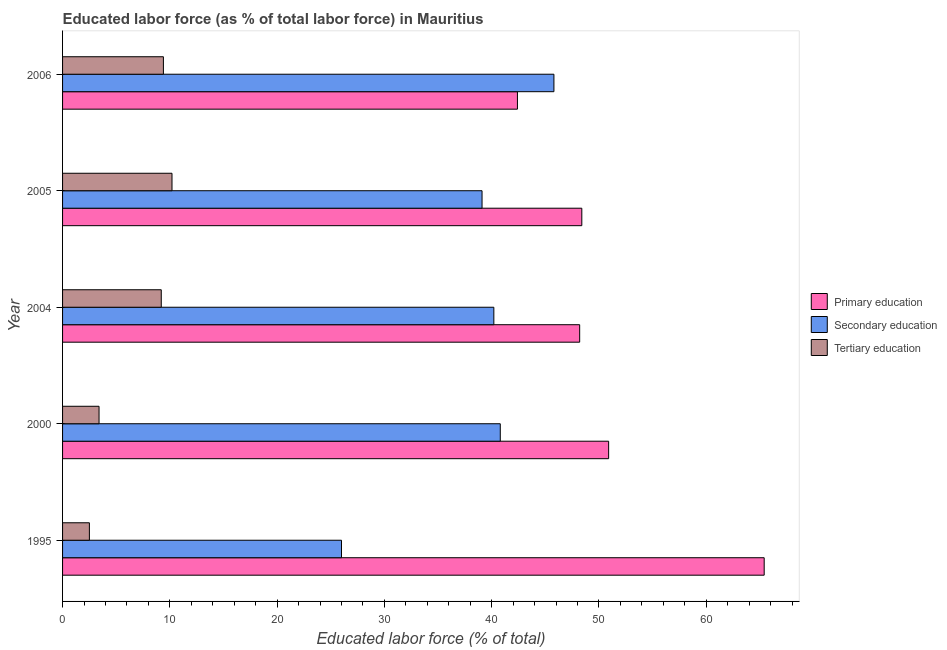Are the number of bars per tick equal to the number of legend labels?
Keep it short and to the point. Yes. Are the number of bars on each tick of the Y-axis equal?
Offer a terse response. Yes. In how many cases, is the number of bars for a given year not equal to the number of legend labels?
Your answer should be very brief. 0. What is the percentage of labor force who received primary education in 1995?
Provide a short and direct response. 65.4. Across all years, what is the maximum percentage of labor force who received primary education?
Offer a very short reply. 65.4. In which year was the percentage of labor force who received secondary education maximum?
Provide a short and direct response. 2006. What is the total percentage of labor force who received tertiary education in the graph?
Keep it short and to the point. 34.7. What is the difference between the percentage of labor force who received tertiary education in 2004 and that in 2005?
Offer a very short reply. -1. What is the difference between the percentage of labor force who received primary education in 1995 and the percentage of labor force who received secondary education in 2005?
Provide a short and direct response. 26.3. What is the average percentage of labor force who received secondary education per year?
Provide a succinct answer. 38.38. In how many years, is the percentage of labor force who received tertiary education greater than 54 %?
Make the answer very short. 0. What is the ratio of the percentage of labor force who received primary education in 2000 to that in 2004?
Your response must be concise. 1.06. Is the difference between the percentage of labor force who received tertiary education in 2000 and 2006 greater than the difference between the percentage of labor force who received primary education in 2000 and 2006?
Offer a very short reply. No. What is the difference between the highest and the second highest percentage of labor force who received secondary education?
Make the answer very short. 5. What is the difference between the highest and the lowest percentage of labor force who received secondary education?
Make the answer very short. 19.8. In how many years, is the percentage of labor force who received secondary education greater than the average percentage of labor force who received secondary education taken over all years?
Provide a short and direct response. 4. Is the sum of the percentage of labor force who received tertiary education in 1995 and 2004 greater than the maximum percentage of labor force who received secondary education across all years?
Offer a very short reply. No. What does the 3rd bar from the bottom in 2000 represents?
Offer a terse response. Tertiary education. How many years are there in the graph?
Provide a succinct answer. 5. What is the difference between two consecutive major ticks on the X-axis?
Make the answer very short. 10. Does the graph contain grids?
Offer a terse response. No. Where does the legend appear in the graph?
Your answer should be very brief. Center right. How many legend labels are there?
Offer a terse response. 3. How are the legend labels stacked?
Give a very brief answer. Vertical. What is the title of the graph?
Offer a very short reply. Educated labor force (as % of total labor force) in Mauritius. What is the label or title of the X-axis?
Provide a succinct answer. Educated labor force (% of total). What is the Educated labor force (% of total) in Primary education in 1995?
Your response must be concise. 65.4. What is the Educated labor force (% of total) in Primary education in 2000?
Ensure brevity in your answer.  50.9. What is the Educated labor force (% of total) in Secondary education in 2000?
Your answer should be very brief. 40.8. What is the Educated labor force (% of total) of Tertiary education in 2000?
Make the answer very short. 3.4. What is the Educated labor force (% of total) in Primary education in 2004?
Your response must be concise. 48.2. What is the Educated labor force (% of total) in Secondary education in 2004?
Give a very brief answer. 40.2. What is the Educated labor force (% of total) of Tertiary education in 2004?
Make the answer very short. 9.2. What is the Educated labor force (% of total) in Primary education in 2005?
Offer a very short reply. 48.4. What is the Educated labor force (% of total) in Secondary education in 2005?
Provide a short and direct response. 39.1. What is the Educated labor force (% of total) in Tertiary education in 2005?
Offer a very short reply. 10.2. What is the Educated labor force (% of total) of Primary education in 2006?
Ensure brevity in your answer.  42.4. What is the Educated labor force (% of total) of Secondary education in 2006?
Make the answer very short. 45.8. What is the Educated labor force (% of total) in Tertiary education in 2006?
Your answer should be compact. 9.4. Across all years, what is the maximum Educated labor force (% of total) of Primary education?
Give a very brief answer. 65.4. Across all years, what is the maximum Educated labor force (% of total) in Secondary education?
Ensure brevity in your answer.  45.8. Across all years, what is the maximum Educated labor force (% of total) of Tertiary education?
Ensure brevity in your answer.  10.2. Across all years, what is the minimum Educated labor force (% of total) of Primary education?
Give a very brief answer. 42.4. Across all years, what is the minimum Educated labor force (% of total) of Secondary education?
Your answer should be very brief. 26. What is the total Educated labor force (% of total) of Primary education in the graph?
Keep it short and to the point. 255.3. What is the total Educated labor force (% of total) of Secondary education in the graph?
Provide a succinct answer. 191.9. What is the total Educated labor force (% of total) of Tertiary education in the graph?
Your answer should be compact. 34.7. What is the difference between the Educated labor force (% of total) of Primary education in 1995 and that in 2000?
Your answer should be compact. 14.5. What is the difference between the Educated labor force (% of total) of Secondary education in 1995 and that in 2000?
Keep it short and to the point. -14.8. What is the difference between the Educated labor force (% of total) of Tertiary education in 1995 and that in 2000?
Provide a succinct answer. -0.9. What is the difference between the Educated labor force (% of total) in Secondary education in 1995 and that in 2004?
Offer a terse response. -14.2. What is the difference between the Educated labor force (% of total) in Tertiary education in 1995 and that in 2004?
Ensure brevity in your answer.  -6.7. What is the difference between the Educated labor force (% of total) of Secondary education in 1995 and that in 2006?
Offer a terse response. -19.8. What is the difference between the Educated labor force (% of total) in Tertiary education in 1995 and that in 2006?
Ensure brevity in your answer.  -6.9. What is the difference between the Educated labor force (% of total) of Secondary education in 2000 and that in 2004?
Your answer should be very brief. 0.6. What is the difference between the Educated labor force (% of total) in Primary education in 2000 and that in 2005?
Your answer should be very brief. 2.5. What is the difference between the Educated labor force (% of total) of Secondary education in 2000 and that in 2005?
Give a very brief answer. 1.7. What is the difference between the Educated labor force (% of total) of Primary education in 2000 and that in 2006?
Your answer should be very brief. 8.5. What is the difference between the Educated labor force (% of total) of Tertiary education in 2000 and that in 2006?
Ensure brevity in your answer.  -6. What is the difference between the Educated labor force (% of total) of Primary education in 2005 and that in 2006?
Ensure brevity in your answer.  6. What is the difference between the Educated labor force (% of total) in Secondary education in 2005 and that in 2006?
Your answer should be very brief. -6.7. What is the difference between the Educated labor force (% of total) of Primary education in 1995 and the Educated labor force (% of total) of Secondary education in 2000?
Make the answer very short. 24.6. What is the difference between the Educated labor force (% of total) of Primary education in 1995 and the Educated labor force (% of total) of Tertiary education in 2000?
Make the answer very short. 62. What is the difference between the Educated labor force (% of total) of Secondary education in 1995 and the Educated labor force (% of total) of Tertiary education in 2000?
Offer a terse response. 22.6. What is the difference between the Educated labor force (% of total) of Primary education in 1995 and the Educated labor force (% of total) of Secondary education in 2004?
Make the answer very short. 25.2. What is the difference between the Educated labor force (% of total) of Primary education in 1995 and the Educated labor force (% of total) of Tertiary education in 2004?
Provide a short and direct response. 56.2. What is the difference between the Educated labor force (% of total) in Secondary education in 1995 and the Educated labor force (% of total) in Tertiary education in 2004?
Give a very brief answer. 16.8. What is the difference between the Educated labor force (% of total) in Primary education in 1995 and the Educated labor force (% of total) in Secondary education in 2005?
Your answer should be compact. 26.3. What is the difference between the Educated labor force (% of total) of Primary education in 1995 and the Educated labor force (% of total) of Tertiary education in 2005?
Provide a short and direct response. 55.2. What is the difference between the Educated labor force (% of total) of Secondary education in 1995 and the Educated labor force (% of total) of Tertiary education in 2005?
Provide a succinct answer. 15.8. What is the difference between the Educated labor force (% of total) in Primary education in 1995 and the Educated labor force (% of total) in Secondary education in 2006?
Keep it short and to the point. 19.6. What is the difference between the Educated labor force (% of total) in Primary education in 1995 and the Educated labor force (% of total) in Tertiary education in 2006?
Provide a succinct answer. 56. What is the difference between the Educated labor force (% of total) in Secondary education in 1995 and the Educated labor force (% of total) in Tertiary education in 2006?
Offer a terse response. 16.6. What is the difference between the Educated labor force (% of total) in Primary education in 2000 and the Educated labor force (% of total) in Secondary education in 2004?
Your answer should be very brief. 10.7. What is the difference between the Educated labor force (% of total) in Primary education in 2000 and the Educated labor force (% of total) in Tertiary education in 2004?
Your answer should be very brief. 41.7. What is the difference between the Educated labor force (% of total) in Secondary education in 2000 and the Educated labor force (% of total) in Tertiary education in 2004?
Offer a terse response. 31.6. What is the difference between the Educated labor force (% of total) of Primary education in 2000 and the Educated labor force (% of total) of Secondary education in 2005?
Your answer should be compact. 11.8. What is the difference between the Educated labor force (% of total) in Primary education in 2000 and the Educated labor force (% of total) in Tertiary education in 2005?
Your answer should be compact. 40.7. What is the difference between the Educated labor force (% of total) in Secondary education in 2000 and the Educated labor force (% of total) in Tertiary education in 2005?
Provide a short and direct response. 30.6. What is the difference between the Educated labor force (% of total) of Primary education in 2000 and the Educated labor force (% of total) of Secondary education in 2006?
Provide a short and direct response. 5.1. What is the difference between the Educated labor force (% of total) in Primary education in 2000 and the Educated labor force (% of total) in Tertiary education in 2006?
Provide a succinct answer. 41.5. What is the difference between the Educated labor force (% of total) of Secondary education in 2000 and the Educated labor force (% of total) of Tertiary education in 2006?
Make the answer very short. 31.4. What is the difference between the Educated labor force (% of total) of Primary education in 2004 and the Educated labor force (% of total) of Tertiary education in 2006?
Offer a terse response. 38.8. What is the difference between the Educated labor force (% of total) of Secondary education in 2004 and the Educated labor force (% of total) of Tertiary education in 2006?
Offer a very short reply. 30.8. What is the difference between the Educated labor force (% of total) of Primary education in 2005 and the Educated labor force (% of total) of Secondary education in 2006?
Provide a short and direct response. 2.6. What is the difference between the Educated labor force (% of total) in Secondary education in 2005 and the Educated labor force (% of total) in Tertiary education in 2006?
Offer a very short reply. 29.7. What is the average Educated labor force (% of total) in Primary education per year?
Make the answer very short. 51.06. What is the average Educated labor force (% of total) in Secondary education per year?
Your answer should be very brief. 38.38. What is the average Educated labor force (% of total) in Tertiary education per year?
Your answer should be very brief. 6.94. In the year 1995, what is the difference between the Educated labor force (% of total) of Primary education and Educated labor force (% of total) of Secondary education?
Provide a succinct answer. 39.4. In the year 1995, what is the difference between the Educated labor force (% of total) of Primary education and Educated labor force (% of total) of Tertiary education?
Your answer should be very brief. 62.9. In the year 2000, what is the difference between the Educated labor force (% of total) of Primary education and Educated labor force (% of total) of Secondary education?
Give a very brief answer. 10.1. In the year 2000, what is the difference between the Educated labor force (% of total) in Primary education and Educated labor force (% of total) in Tertiary education?
Ensure brevity in your answer.  47.5. In the year 2000, what is the difference between the Educated labor force (% of total) in Secondary education and Educated labor force (% of total) in Tertiary education?
Provide a short and direct response. 37.4. In the year 2004, what is the difference between the Educated labor force (% of total) of Primary education and Educated labor force (% of total) of Secondary education?
Provide a succinct answer. 8. In the year 2004, what is the difference between the Educated labor force (% of total) in Secondary education and Educated labor force (% of total) in Tertiary education?
Keep it short and to the point. 31. In the year 2005, what is the difference between the Educated labor force (% of total) of Primary education and Educated labor force (% of total) of Secondary education?
Your answer should be very brief. 9.3. In the year 2005, what is the difference between the Educated labor force (% of total) in Primary education and Educated labor force (% of total) in Tertiary education?
Your answer should be compact. 38.2. In the year 2005, what is the difference between the Educated labor force (% of total) in Secondary education and Educated labor force (% of total) in Tertiary education?
Keep it short and to the point. 28.9. In the year 2006, what is the difference between the Educated labor force (% of total) of Primary education and Educated labor force (% of total) of Secondary education?
Give a very brief answer. -3.4. In the year 2006, what is the difference between the Educated labor force (% of total) of Secondary education and Educated labor force (% of total) of Tertiary education?
Offer a very short reply. 36.4. What is the ratio of the Educated labor force (% of total) of Primary education in 1995 to that in 2000?
Provide a short and direct response. 1.28. What is the ratio of the Educated labor force (% of total) in Secondary education in 1995 to that in 2000?
Keep it short and to the point. 0.64. What is the ratio of the Educated labor force (% of total) of Tertiary education in 1995 to that in 2000?
Make the answer very short. 0.74. What is the ratio of the Educated labor force (% of total) of Primary education in 1995 to that in 2004?
Your response must be concise. 1.36. What is the ratio of the Educated labor force (% of total) of Secondary education in 1995 to that in 2004?
Your answer should be compact. 0.65. What is the ratio of the Educated labor force (% of total) of Tertiary education in 1995 to that in 2004?
Your answer should be compact. 0.27. What is the ratio of the Educated labor force (% of total) in Primary education in 1995 to that in 2005?
Make the answer very short. 1.35. What is the ratio of the Educated labor force (% of total) of Secondary education in 1995 to that in 2005?
Ensure brevity in your answer.  0.67. What is the ratio of the Educated labor force (% of total) in Tertiary education in 1995 to that in 2005?
Your response must be concise. 0.25. What is the ratio of the Educated labor force (% of total) of Primary education in 1995 to that in 2006?
Your answer should be compact. 1.54. What is the ratio of the Educated labor force (% of total) of Secondary education in 1995 to that in 2006?
Give a very brief answer. 0.57. What is the ratio of the Educated labor force (% of total) in Tertiary education in 1995 to that in 2006?
Offer a terse response. 0.27. What is the ratio of the Educated labor force (% of total) of Primary education in 2000 to that in 2004?
Keep it short and to the point. 1.06. What is the ratio of the Educated labor force (% of total) of Secondary education in 2000 to that in 2004?
Make the answer very short. 1.01. What is the ratio of the Educated labor force (% of total) in Tertiary education in 2000 to that in 2004?
Provide a short and direct response. 0.37. What is the ratio of the Educated labor force (% of total) of Primary education in 2000 to that in 2005?
Your answer should be very brief. 1.05. What is the ratio of the Educated labor force (% of total) in Secondary education in 2000 to that in 2005?
Provide a succinct answer. 1.04. What is the ratio of the Educated labor force (% of total) of Tertiary education in 2000 to that in 2005?
Offer a terse response. 0.33. What is the ratio of the Educated labor force (% of total) in Primary education in 2000 to that in 2006?
Offer a very short reply. 1.2. What is the ratio of the Educated labor force (% of total) of Secondary education in 2000 to that in 2006?
Provide a succinct answer. 0.89. What is the ratio of the Educated labor force (% of total) in Tertiary education in 2000 to that in 2006?
Your answer should be compact. 0.36. What is the ratio of the Educated labor force (% of total) in Primary education in 2004 to that in 2005?
Give a very brief answer. 1. What is the ratio of the Educated labor force (% of total) in Secondary education in 2004 to that in 2005?
Your response must be concise. 1.03. What is the ratio of the Educated labor force (% of total) of Tertiary education in 2004 to that in 2005?
Make the answer very short. 0.9. What is the ratio of the Educated labor force (% of total) of Primary education in 2004 to that in 2006?
Your answer should be compact. 1.14. What is the ratio of the Educated labor force (% of total) of Secondary education in 2004 to that in 2006?
Your answer should be compact. 0.88. What is the ratio of the Educated labor force (% of total) in Tertiary education in 2004 to that in 2006?
Make the answer very short. 0.98. What is the ratio of the Educated labor force (% of total) in Primary education in 2005 to that in 2006?
Offer a very short reply. 1.14. What is the ratio of the Educated labor force (% of total) of Secondary education in 2005 to that in 2006?
Keep it short and to the point. 0.85. What is the ratio of the Educated labor force (% of total) of Tertiary education in 2005 to that in 2006?
Offer a terse response. 1.09. What is the difference between the highest and the second highest Educated labor force (% of total) in Secondary education?
Offer a terse response. 5. What is the difference between the highest and the second highest Educated labor force (% of total) of Tertiary education?
Your answer should be compact. 0.8. What is the difference between the highest and the lowest Educated labor force (% of total) of Primary education?
Keep it short and to the point. 23. What is the difference between the highest and the lowest Educated labor force (% of total) of Secondary education?
Ensure brevity in your answer.  19.8. What is the difference between the highest and the lowest Educated labor force (% of total) of Tertiary education?
Your response must be concise. 7.7. 